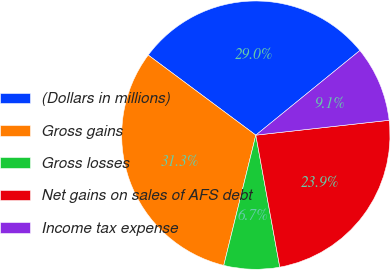<chart> <loc_0><loc_0><loc_500><loc_500><pie_chart><fcel>(Dollars in millions)<fcel>Gross gains<fcel>Gross losses<fcel>Net gains on sales of AFS debt<fcel>Income tax expense<nl><fcel>28.95%<fcel>31.34%<fcel>6.7%<fcel>23.91%<fcel>9.1%<nl></chart> 